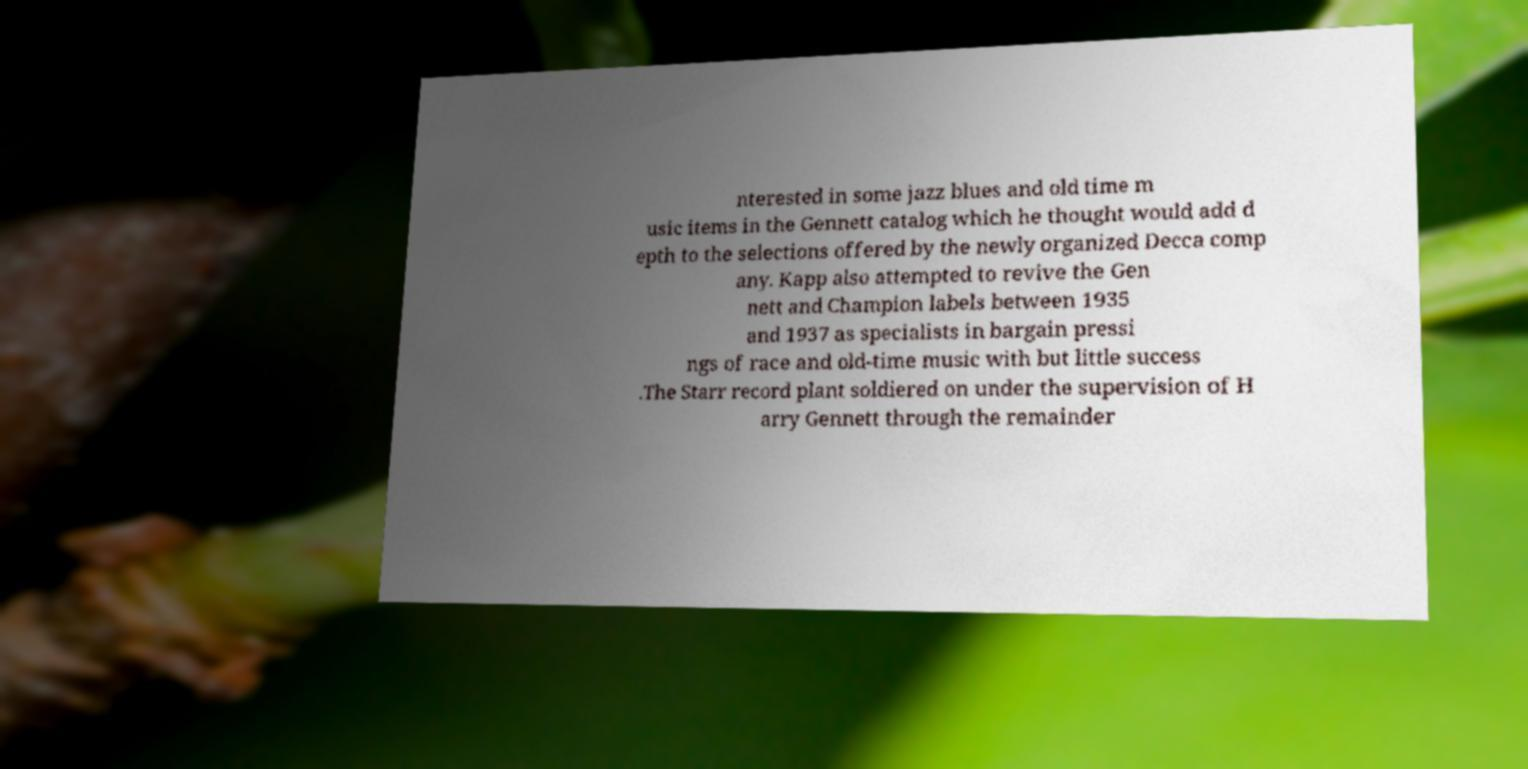What messages or text are displayed in this image? I need them in a readable, typed format. nterested in some jazz blues and old time m usic items in the Gennett catalog which he thought would add d epth to the selections offered by the newly organized Decca comp any. Kapp also attempted to revive the Gen nett and Champion labels between 1935 and 1937 as specialists in bargain pressi ngs of race and old-time music with but little success .The Starr record plant soldiered on under the supervision of H arry Gennett through the remainder 